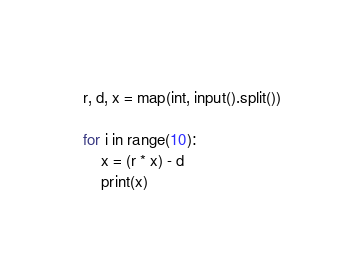Convert code to text. <code><loc_0><loc_0><loc_500><loc_500><_Python_>r, d, x = map(int, input().split())

for i in range(10):
    x = (r * x) - d
    print(x)</code> 